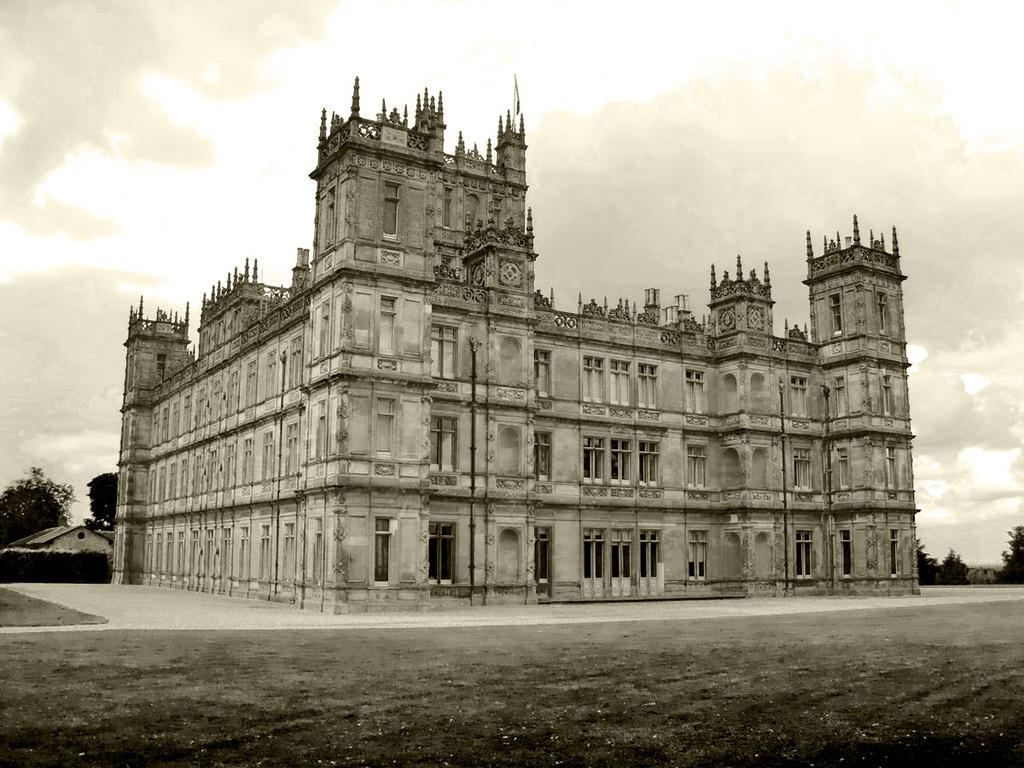What is at the bottom of the image? There is a ground at the bottom of the image. What can be seen in the background of the image? There are trees, buildings, and clouds in the sky in the background of the image. What type of zephyr can be seen blowing through the trees in the image? There is no zephyr present in the image; it is a term used to describe a gentle breeze, and there is no mention of wind or breeze in the provided facts. 